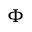Convert formula to latex. <formula><loc_0><loc_0><loc_500><loc_500>\Phi</formula> 